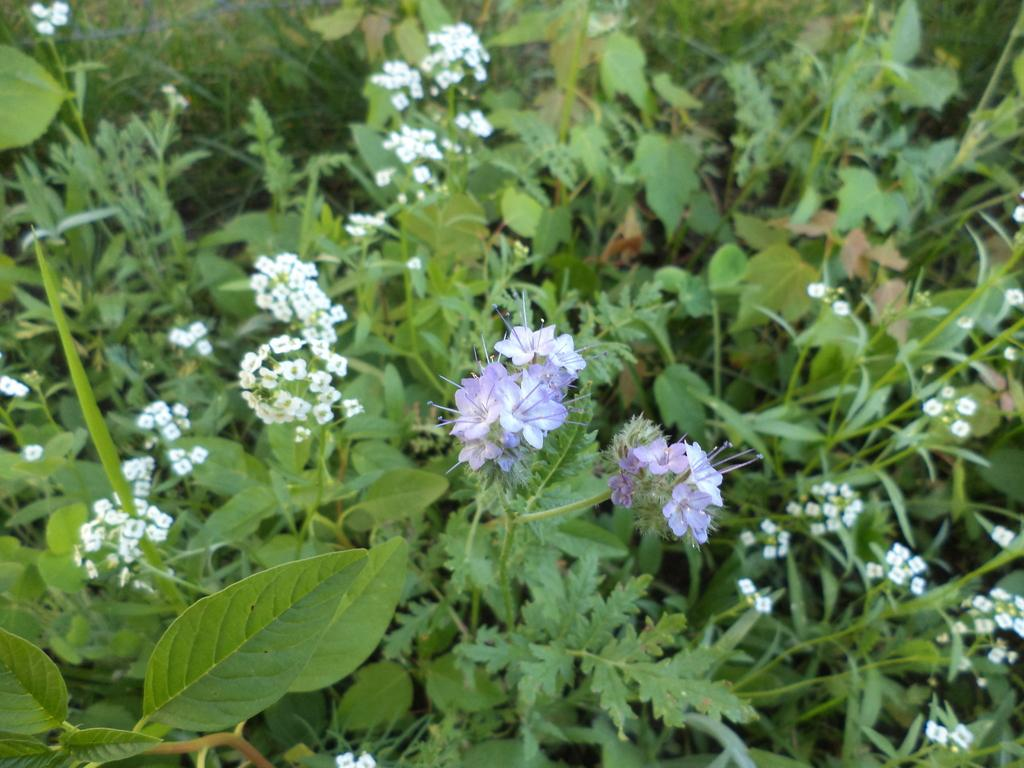What type of living organisms can be seen in the image? There are flowers in the image. What colors are the flowers in the image? The flowers are purple and white in color. What color are the plants in the image? The plants in the image are green in color. What is the name of the person sleeping on the pan in the image? There is no person sleeping on a pan in the image; it only features flowers and plants. 